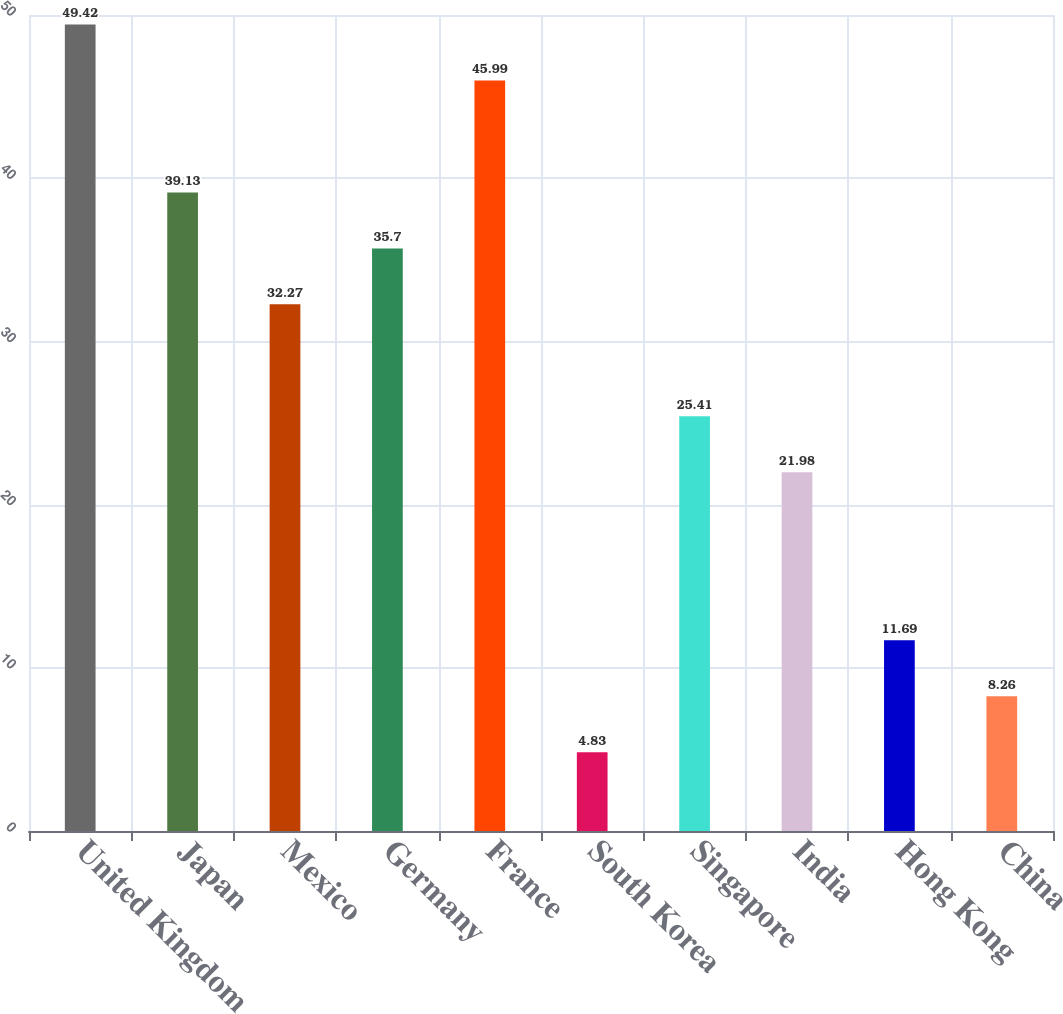Convert chart. <chart><loc_0><loc_0><loc_500><loc_500><bar_chart><fcel>United Kingdom<fcel>Japan<fcel>Mexico<fcel>Germany<fcel>France<fcel>South Korea<fcel>Singapore<fcel>India<fcel>Hong Kong<fcel>China<nl><fcel>49.42<fcel>39.13<fcel>32.27<fcel>35.7<fcel>45.99<fcel>4.83<fcel>25.41<fcel>21.98<fcel>11.69<fcel>8.26<nl></chart> 